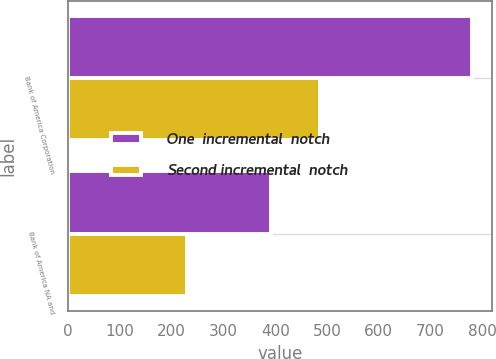<chart> <loc_0><loc_0><loc_500><loc_500><stacked_bar_chart><ecel><fcel>Bank of America Corporation<fcel>Bank of America NA and<nl><fcel>One  incremental  notch<fcel>779<fcel>391<nl><fcel>Second incremental  notch<fcel>487<fcel>230<nl></chart> 